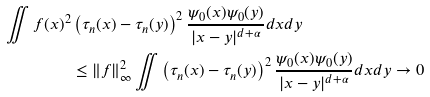<formula> <loc_0><loc_0><loc_500><loc_500>\iint f ( x ) ^ { 2 } & \left ( \tau _ { n } ( x ) - \tau _ { n } ( y ) \right ) ^ { 2 } \frac { \psi _ { 0 } ( x ) \psi _ { 0 } ( y ) } { | x - y | ^ { d + \alpha } } d x d y \\ & \leq \| f \| _ { \infty } ^ { 2 } \iint \left ( \tau _ { n } ( x ) - \tau _ { n } ( y ) \right ) ^ { 2 } \frac { \psi _ { 0 } ( x ) \psi _ { 0 } ( y ) } { | x - y | ^ { d + \alpha } } d x d y \rightarrow 0</formula> 